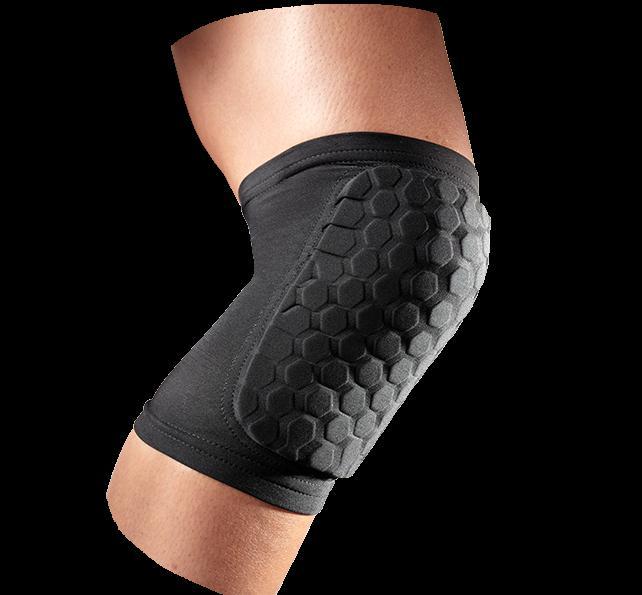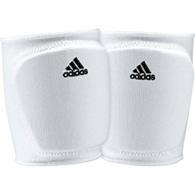The first image is the image on the left, the second image is the image on the right. For the images displayed, is the sentence "Together, the images include both white knee pads and black knee pads only." factually correct? Answer yes or no. Yes. 